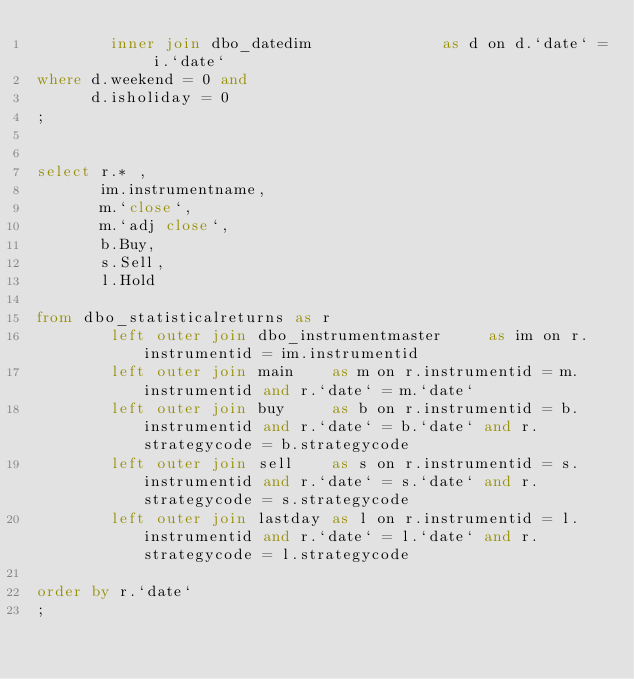<code> <loc_0><loc_0><loc_500><loc_500><_SQL_>        inner join dbo_datedim              as d on d.`date` = i.`date`
where d.weekend = 0 and 
      d.isholiday = 0
;


select r.* ,
       im.instrumentname,
       m.`close`,
       m.`adj close`,
       b.Buy,
       s.Sell,
       l.Hold
       
from dbo_statisticalreturns as r
        left outer join dbo_instrumentmaster     as im on r.instrumentid = im.instrumentid
        left outer join main    as m on r.instrumentid = m.instrumentid and r.`date` = m.`date` 
        left outer join buy     as b on r.instrumentid = b.instrumentid and r.`date` = b.`date` and r.strategycode = b.strategycode
        left outer join sell    as s on r.instrumentid = s.instrumentid and r.`date` = s.`date` and r.strategycode = s.strategycode
	    left outer join lastday as l on r.instrumentid = l.instrumentid and r.`date` = l.`date` and r.strategycode = l.strategycode

order by r.`date`
;
</code> 